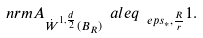Convert formula to latex. <formula><loc_0><loc_0><loc_500><loc_500>\ n r m { A } _ { \dot { W } ^ { 1 , \frac { d } { 2 } } ( B _ { R } ) } \ a l e q _ { \ e p s _ { \ast } , \frac { R } { r } } 1 .</formula> 